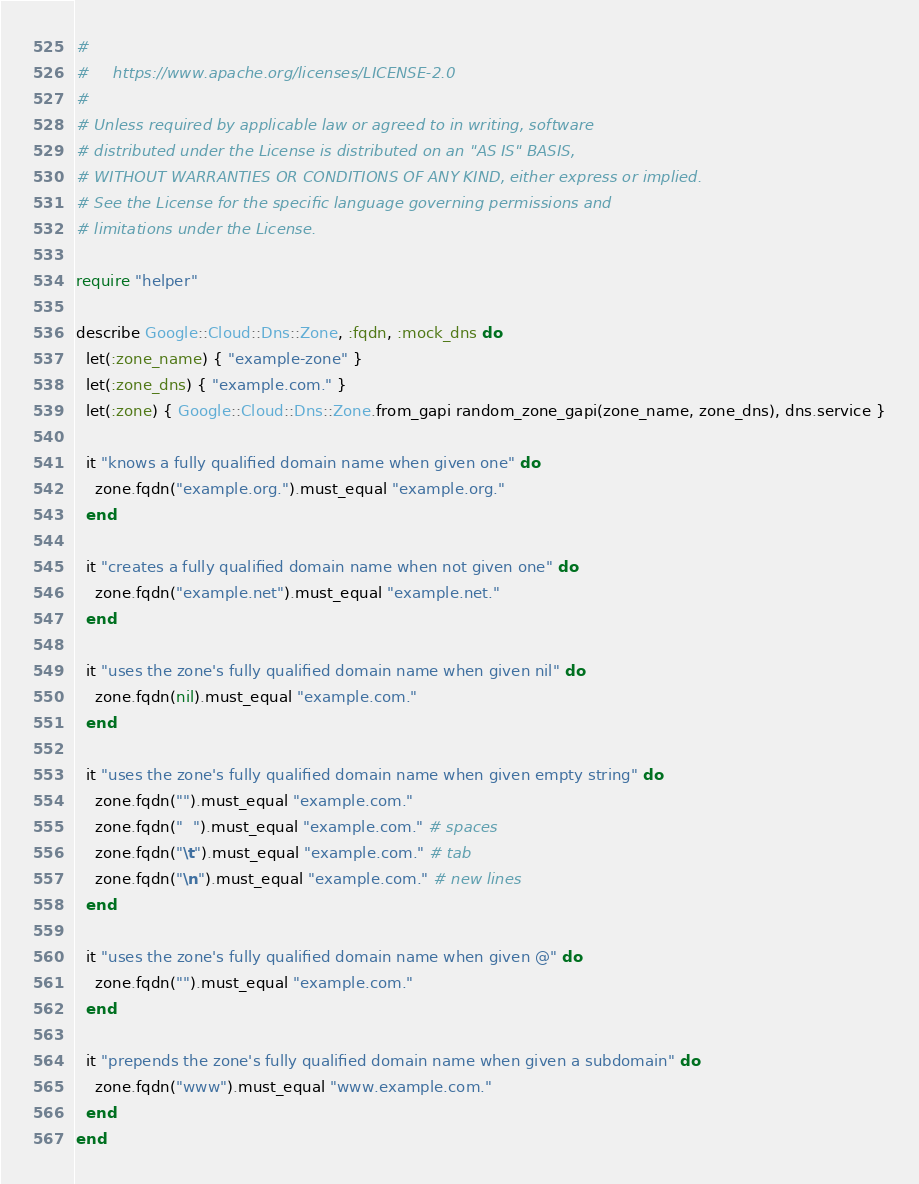<code> <loc_0><loc_0><loc_500><loc_500><_Ruby_>#
#     https://www.apache.org/licenses/LICENSE-2.0
#
# Unless required by applicable law or agreed to in writing, software
# distributed under the License is distributed on an "AS IS" BASIS,
# WITHOUT WARRANTIES OR CONDITIONS OF ANY KIND, either express or implied.
# See the License for the specific language governing permissions and
# limitations under the License.

require "helper"

describe Google::Cloud::Dns::Zone, :fqdn, :mock_dns do
  let(:zone_name) { "example-zone" }
  let(:zone_dns) { "example.com." }
  let(:zone) { Google::Cloud::Dns::Zone.from_gapi random_zone_gapi(zone_name, zone_dns), dns.service }

  it "knows a fully qualified domain name when given one" do
    zone.fqdn("example.org.").must_equal "example.org."
  end

  it "creates a fully qualified domain name when not given one" do
    zone.fqdn("example.net").must_equal "example.net."
  end

  it "uses the zone's fully qualified domain name when given nil" do
    zone.fqdn(nil).must_equal "example.com."
  end

  it "uses the zone's fully qualified domain name when given empty string" do
    zone.fqdn("").must_equal "example.com."
    zone.fqdn("  ").must_equal "example.com." # spaces
    zone.fqdn("\t").must_equal "example.com." # tab
    zone.fqdn("\n").must_equal "example.com." # new lines
  end

  it "uses the zone's fully qualified domain name when given @" do
    zone.fqdn("").must_equal "example.com."
  end

  it "prepends the zone's fully qualified domain name when given a subdomain" do
    zone.fqdn("www").must_equal "www.example.com."
  end
end
</code> 